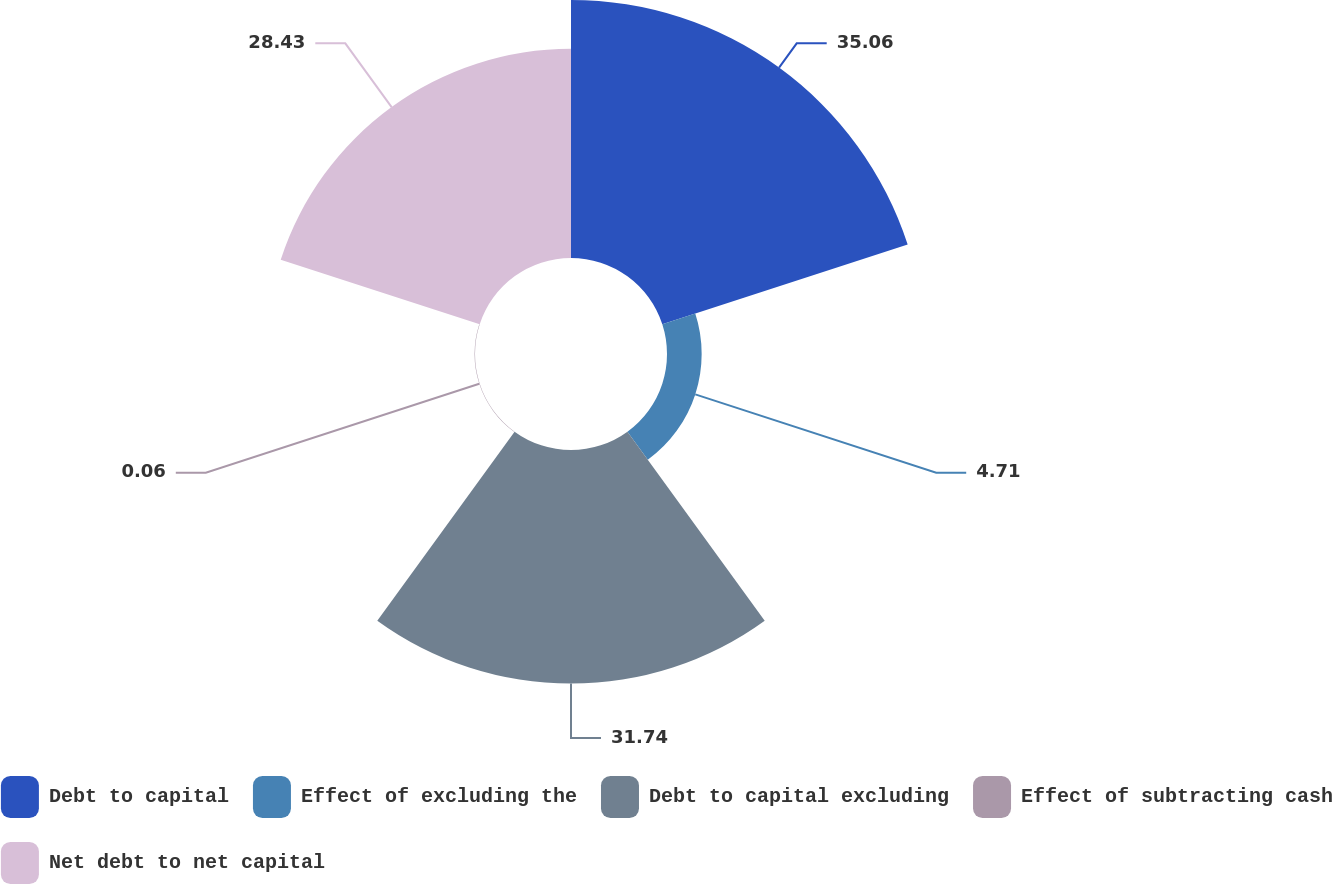Convert chart. <chart><loc_0><loc_0><loc_500><loc_500><pie_chart><fcel>Debt to capital<fcel>Effect of excluding the<fcel>Debt to capital excluding<fcel>Effect of subtracting cash<fcel>Net debt to net capital<nl><fcel>35.06%<fcel>4.71%<fcel>31.74%<fcel>0.06%<fcel>28.43%<nl></chart> 